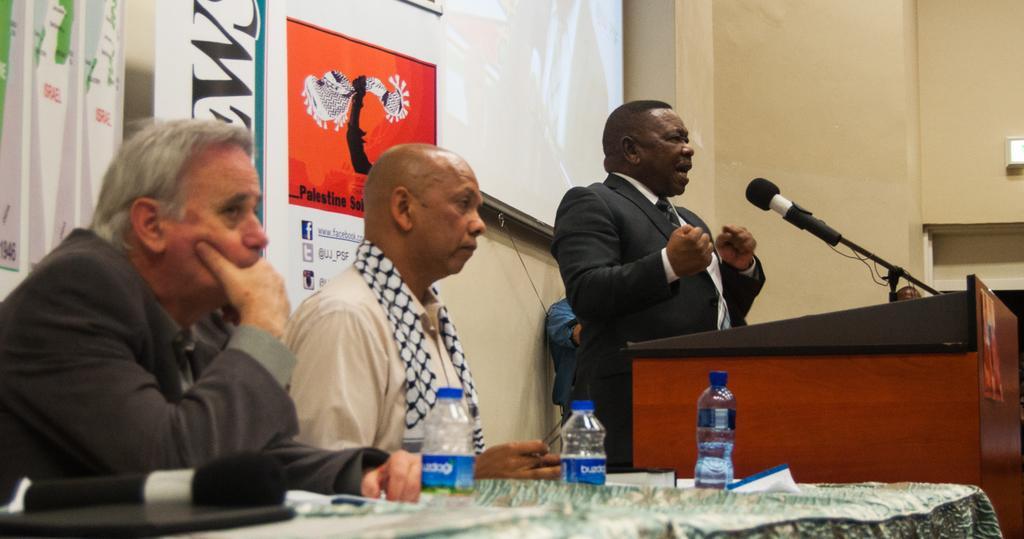In one or two sentences, can you explain what this image depicts? In this image we can see men sitting on the chairs and one is standing at the podium to which mic is attached. We can see a table and on the table there are papers, mics and disposal bottles. In the background there are advertisements to the walls. 